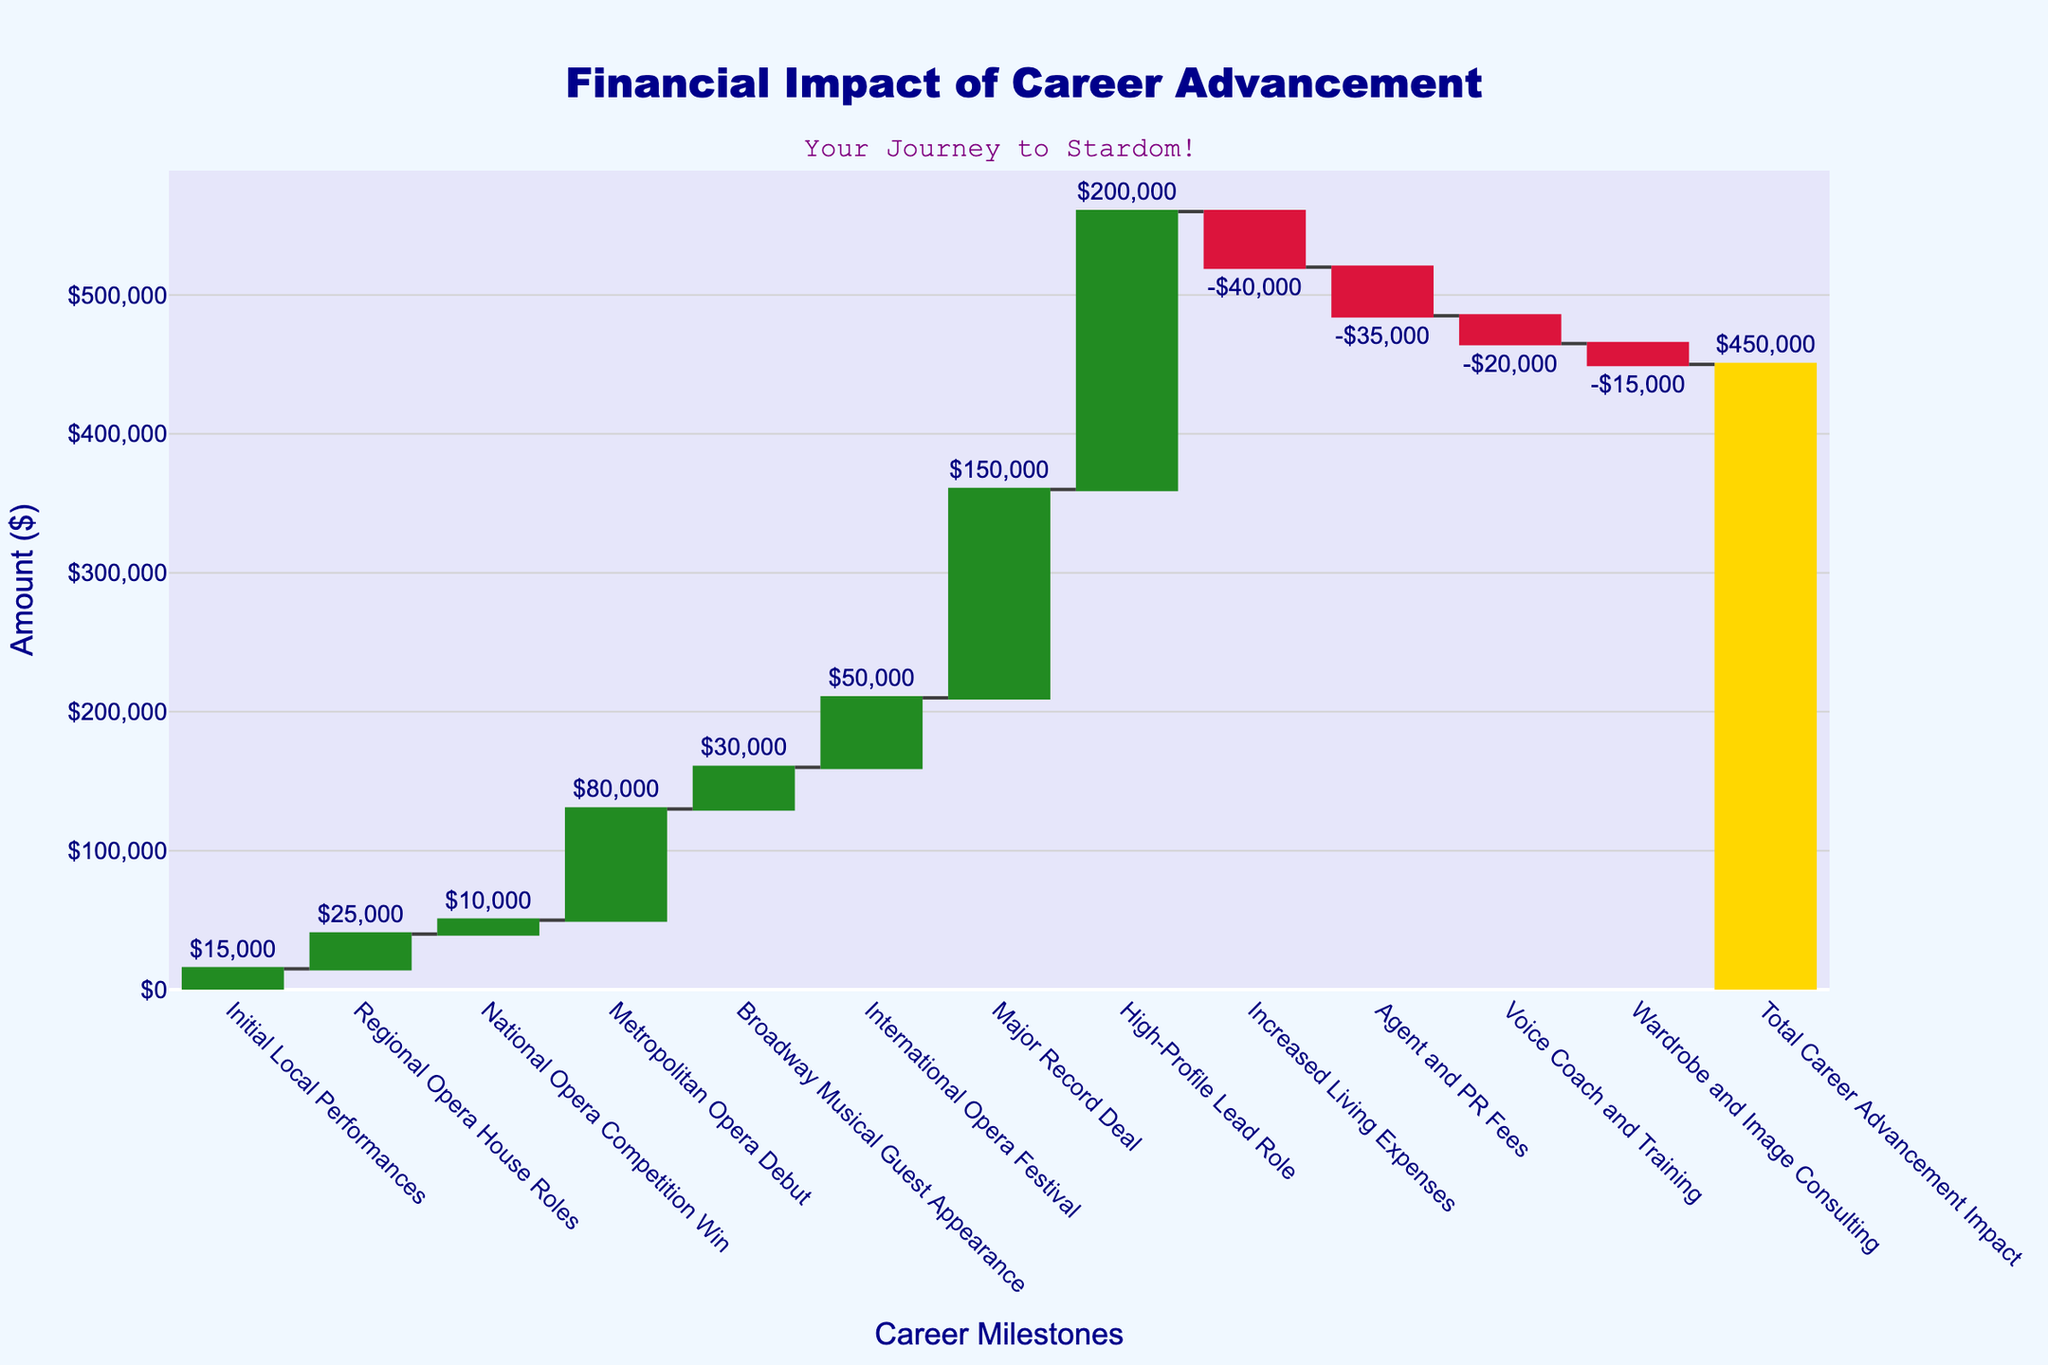What is the title of the chart? The title is displayed at the top of the chart in large font. It reads "Financial Impact of Career Advancement."
Answer: Financial Impact of Career Advancement How many different career milestones are documented in the chart? By counting the data points along the x-axis, we see milestones ranging from "Initial Local Performances" to "High-Profile Lead Role," plus three additional expenses and the "Total Career Advancement Impact" at the end.
Answer: 12 What is the financial impact of the "Metropolitan Opera Debut"? Locate the bar labeled "Metropolitan Opera Debut" and the corresponding text value displayed outside the bar. The value given is $80,000.
Answer: $80,000 What are the career milestones with the highest and lowest positive financial impacts? By comparing the heights of the green bars, we observe that the "High-Profile Lead Role" has the highest positive impact ($200,000) and the "National Opera Competition Win" has the lowest positive impact ($10,000).
Answer: Highest: High-Profile Lead Role, Lowest: National Opera Competition Win What is the total financial gain from all positive career advancements before accounting for expenses? Add the values of all the green bars (positive impacts): $15,000 + $25,000 + $10,000 + $80,000 + $30,000 + $50,000 + $150,000 + $200,000 = $560,000.
Answer: $560,000 What is the combined negative financial impact from "Increased Living Expenses," "Agent and PR Fees," "Voice Coach and Training," and "Wardrobe and Image Consulting"? Add the values of all the red bars (negative impacts): $40,000 + $35,000 + $20,000 + $15,000 = $110,000.
Answer: $110,000 By what amount does the "High-Profile Lead Role" outweigh "Increased Living Expenses"? Subtract the negative value of "Increased Living Expenses" from the positive value of "High-Profile Lead Role": $200,000 - $40,000 = $160,000.
Answer: $160,000 Are there more increases or decreases in financial impact throughout the career progression? By counting the number of green (increasing) and red (decreasing) bars, we find there are 8 increases and 4 decreases.
Answer: More increases What is the financial impact of the three expenses combined compared to the impact of "High-Profile Lead Role"? Sum the three expenses: $40,000 + $35,000 + $20,000 + $15,000 = $110,000. Compare it to "High-Profile Lead Role" ($200,000). The difference is $200,000 - $110,000 = $90,000.
Answer: $90,000 What is the net total impact depicted at the end of the chart? Look at the last bar labeled "Total Career Advancement Impact," which sums up all changes. The total impact is $450,000.
Answer: $450,000 